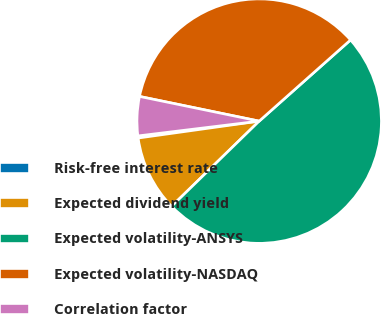Convert chart to OTSL. <chart><loc_0><loc_0><loc_500><loc_500><pie_chart><fcel>Risk-free interest rate<fcel>Expected dividend yield<fcel>Expected volatility-ANSYS<fcel>Expected volatility-NASDAQ<fcel>Correlation factor<nl><fcel>0.28%<fcel>10.07%<fcel>49.28%<fcel>35.2%<fcel>5.17%<nl></chart> 